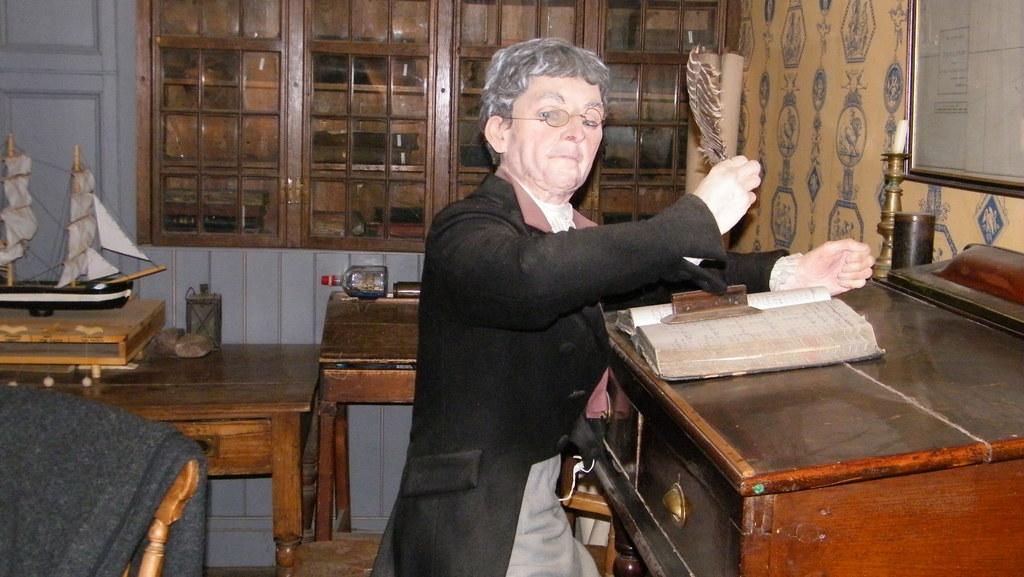Can you describe this image briefly? In this picture we can see a man, in front of him we can see a book on the table, behind to him we can see a miniature. 